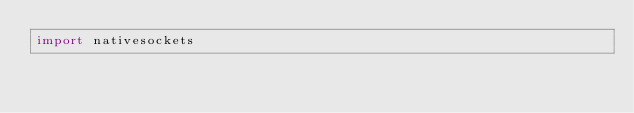<code> <loc_0><loc_0><loc_500><loc_500><_Nim_>import nativesockets
</code> 